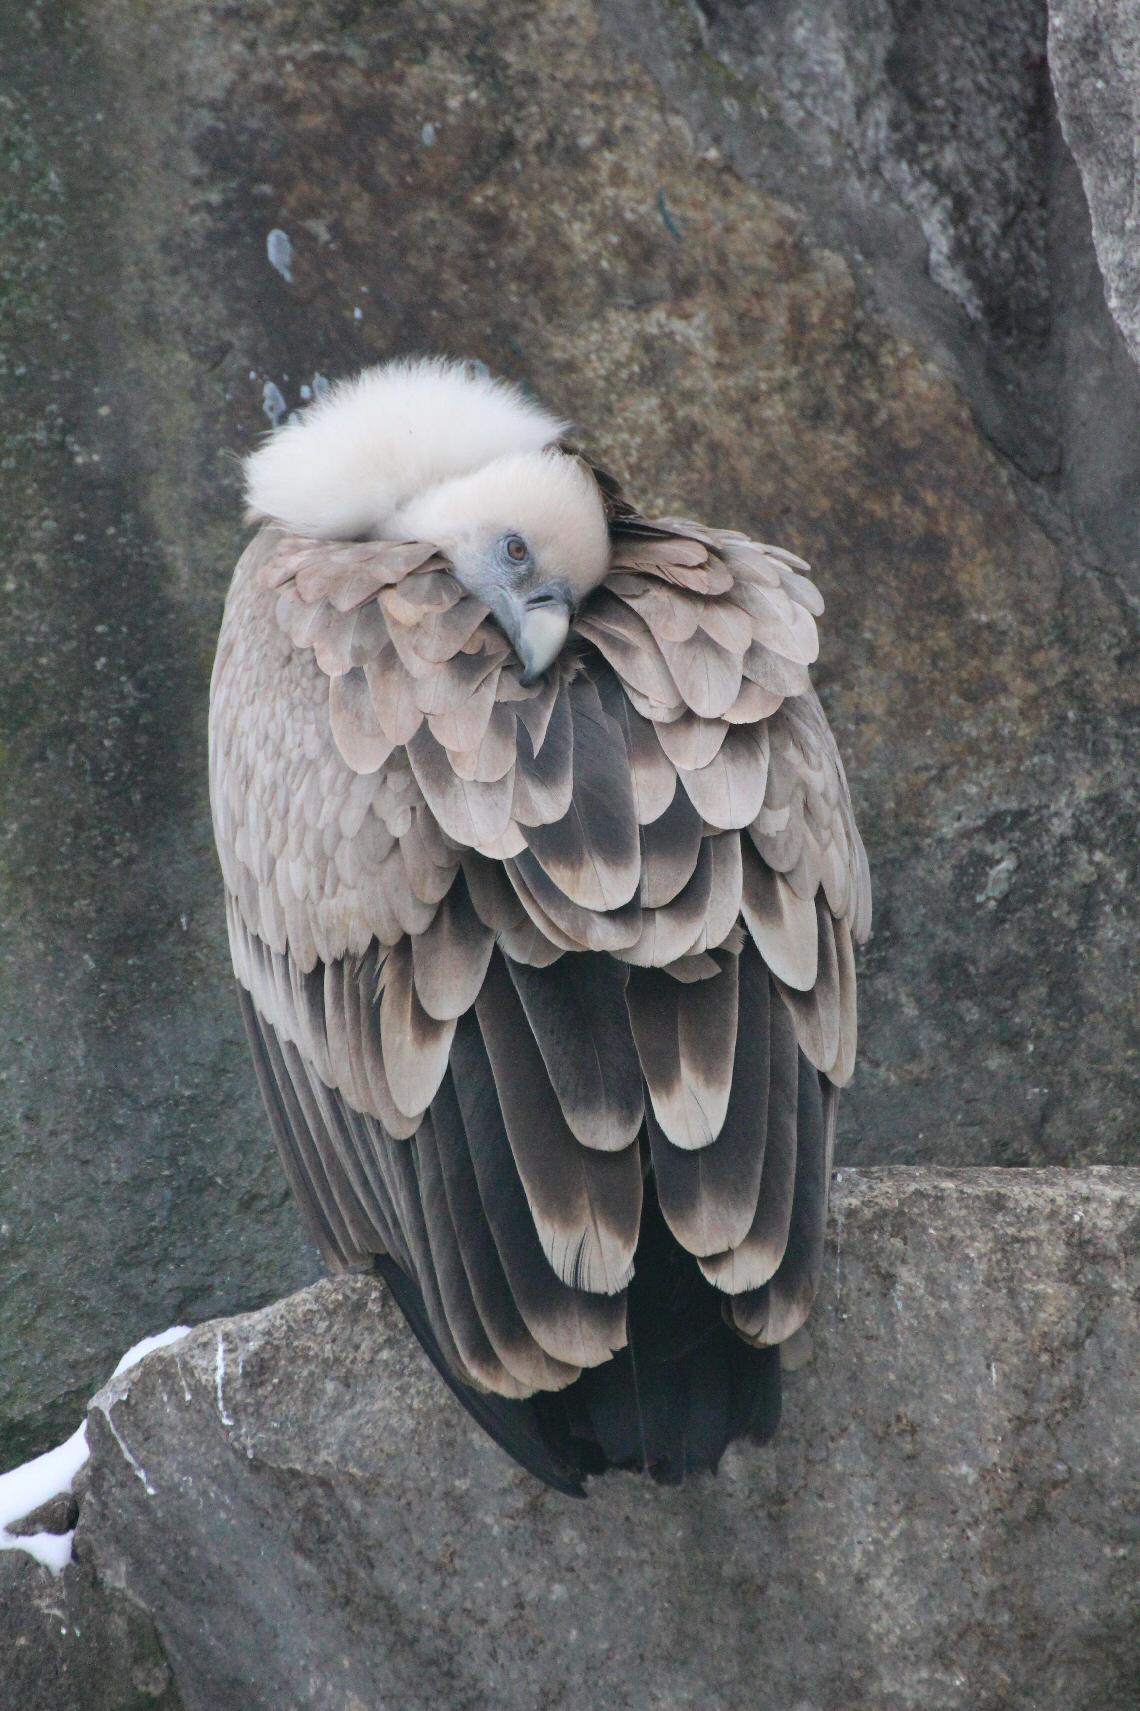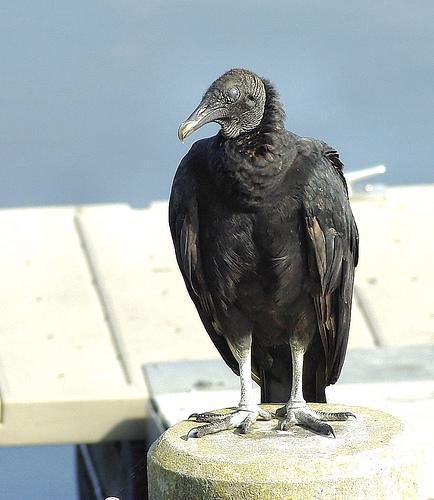The first image is the image on the left, the second image is the image on the right. For the images displayed, is the sentence "An image shows vultures next to a zebra carcass." factually correct? Answer yes or no. No. 